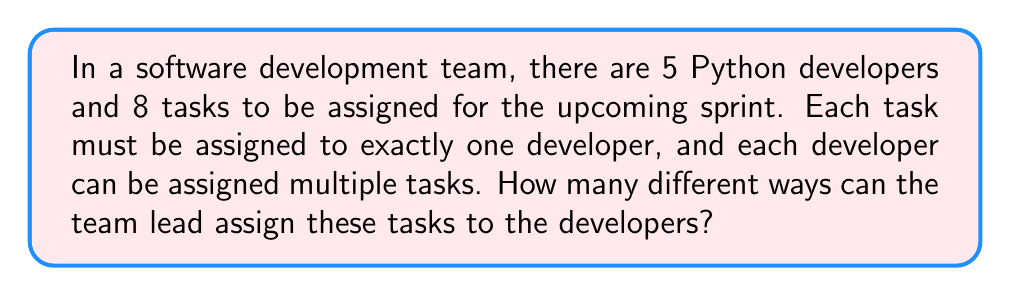What is the answer to this math problem? Let's approach this step-by-step:

1) This is a problem of distributing distinct objects (tasks) into distinct boxes (developers). Each task is distinct and can only go to one developer, but developers can receive multiple tasks.

2) For each task, we have 5 choices (developers) to assign it to.

3) Since there are 8 tasks, and each task has 5 independent choices, we can use the multiplication principle.

4) The total number of ways to assign the tasks is:

   $$5 \times 5 \times 5 \times 5 \times 5 \times 5 \times 5 \times 5 = 5^8$$

5) This can also be written as:

   $$5^8 = 390,625$$

This result represents all possible ways the team lead can assign 8 tasks to 5 developers, allowing for multiple tasks per developer.
Answer: $5^8 = 390,625$ 